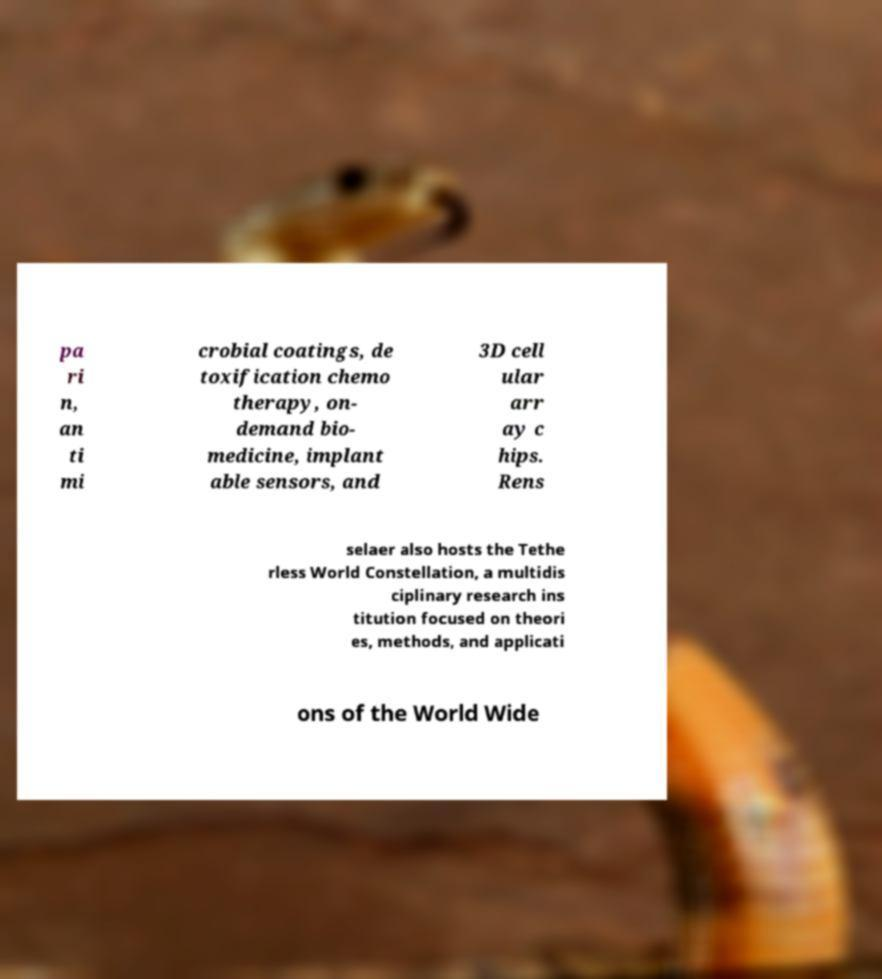Can you read and provide the text displayed in the image?This photo seems to have some interesting text. Can you extract and type it out for me? pa ri n, an ti mi crobial coatings, de toxification chemo therapy, on- demand bio- medicine, implant able sensors, and 3D cell ular arr ay c hips. Rens selaer also hosts the Tethe rless World Constellation, a multidis ciplinary research ins titution focused on theori es, methods, and applicati ons of the World Wide 